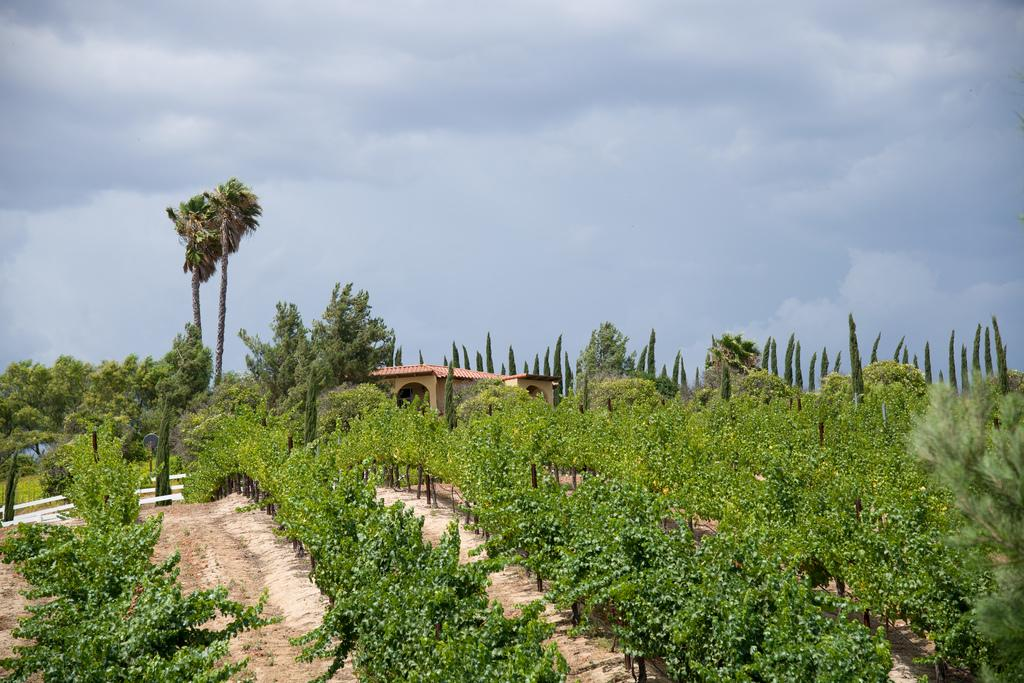What type of vegetation is at the bottom of the image? There are plants at the bottom of the image. What can be seen in the background of the image? There are trees and a house in the background of the image. What is visible at the top of the image? The sky is visible at the top of the image. How many fingers can be seen in the image? There are no fingers visible in the image. Are the sisters in the image playing with the plants? There is no mention of sisters or any people in the image, only plants, trees, a house, and the sky. 